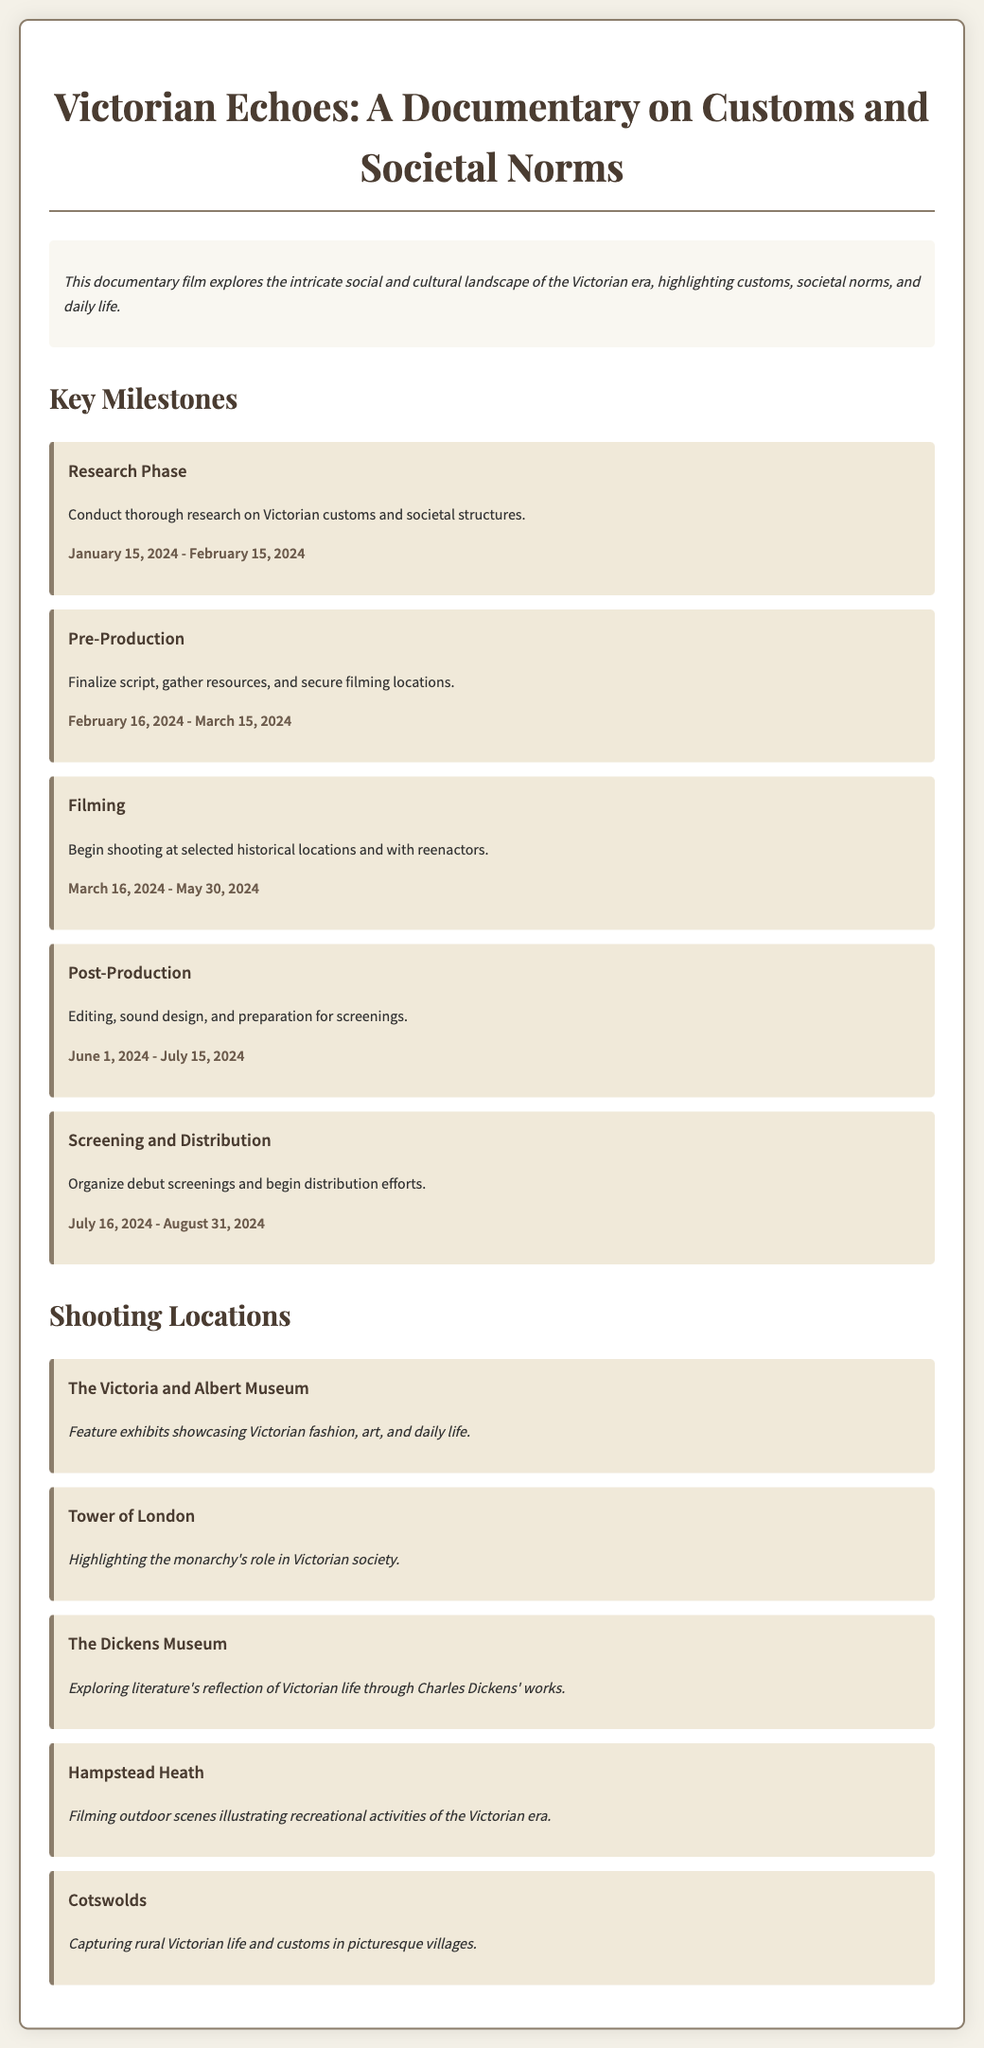What is the title of the documentary? The title of the documentary is stated near the top of the document.
Answer: Victorian Echoes: A Documentary on Customs and Societal Norms When does the research phase start? The start date of the research phase is provided in the milestones section of the document.
Answer: January 15, 2024 What location features exhibits showcasing Victorian fashion? The document specifies locations with relevant descriptions, including the one focusing on fashion.
Answer: The Victoria and Albert Museum What is the end date for the filming phase? The end date for the filming phase is indicated in the milestones part of the document.
Answer: May 30, 2024 How long is the post-production phase? The duration between the start and end dates for post-production provides the answer.
Answer: 45 days Which filming location captures rural Victorian life? The document lists specific locations along with their contextual significance to Victorian life.
Answer: Cotswolds What are the two activities emphasized in the filming process? The document describes key aspects to be focused on during the filming phase, which can be summarized in two activities.
Answer: Shooting at historical locations and with reenactors What is the main focus of the documentary? The document introduces the primary objective of the film which relates to societal aspects.
Answer: Exploring the intricate social and cultural landscape of the Victorian era 